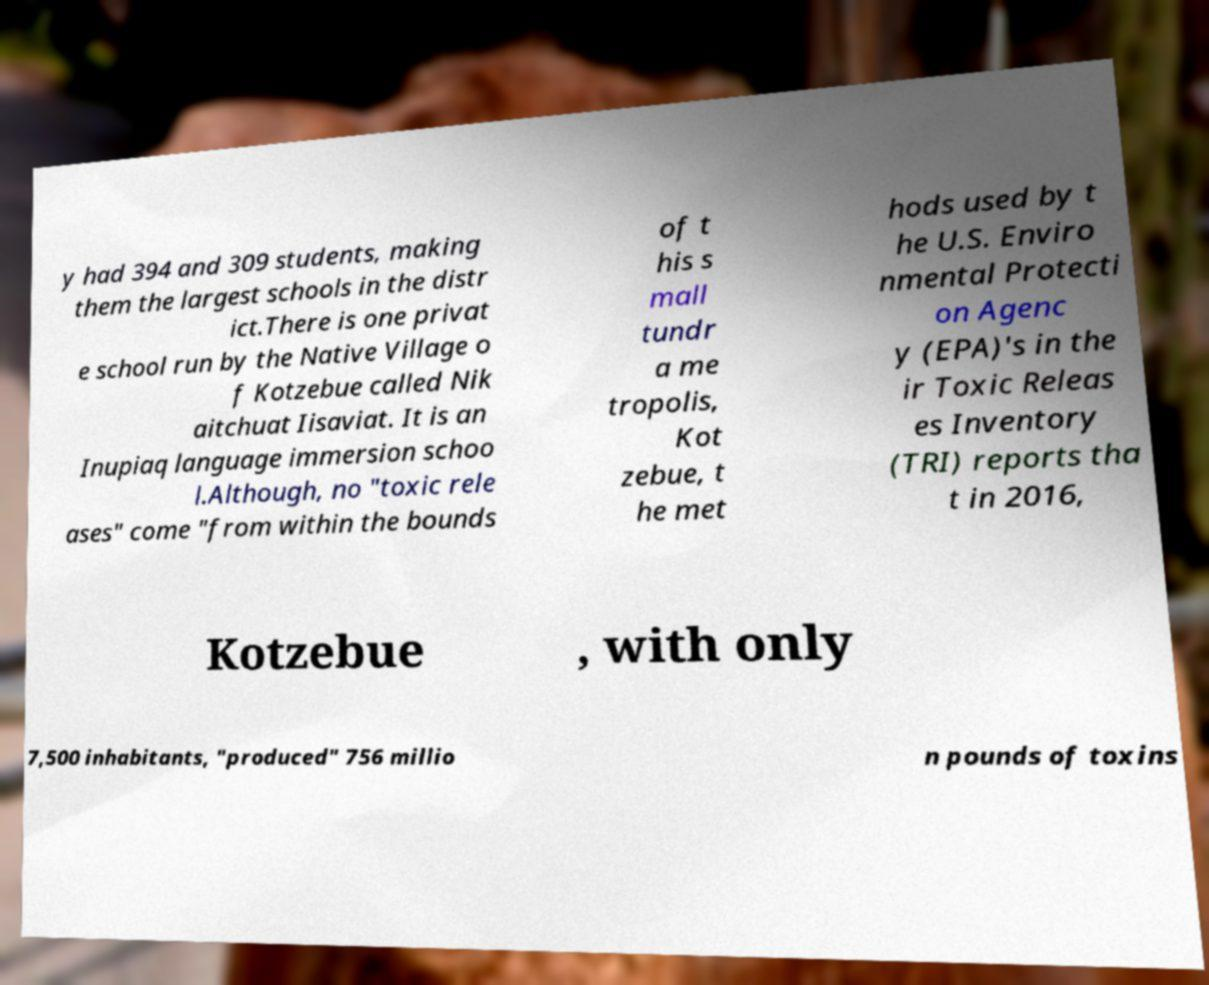Can you read and provide the text displayed in the image?This photo seems to have some interesting text. Can you extract and type it out for me? y had 394 and 309 students, making them the largest schools in the distr ict.There is one privat e school run by the Native Village o f Kotzebue called Nik aitchuat Iisaviat. It is an Inupiaq language immersion schoo l.Although, no "toxic rele ases" come "from within the bounds of t his s mall tundr a me tropolis, Kot zebue, t he met hods used by t he U.S. Enviro nmental Protecti on Agenc y (EPA)'s in the ir Toxic Releas es Inventory (TRI) reports tha t in 2016, Kotzebue , with only 7,500 inhabitants, "produced" 756 millio n pounds of toxins 